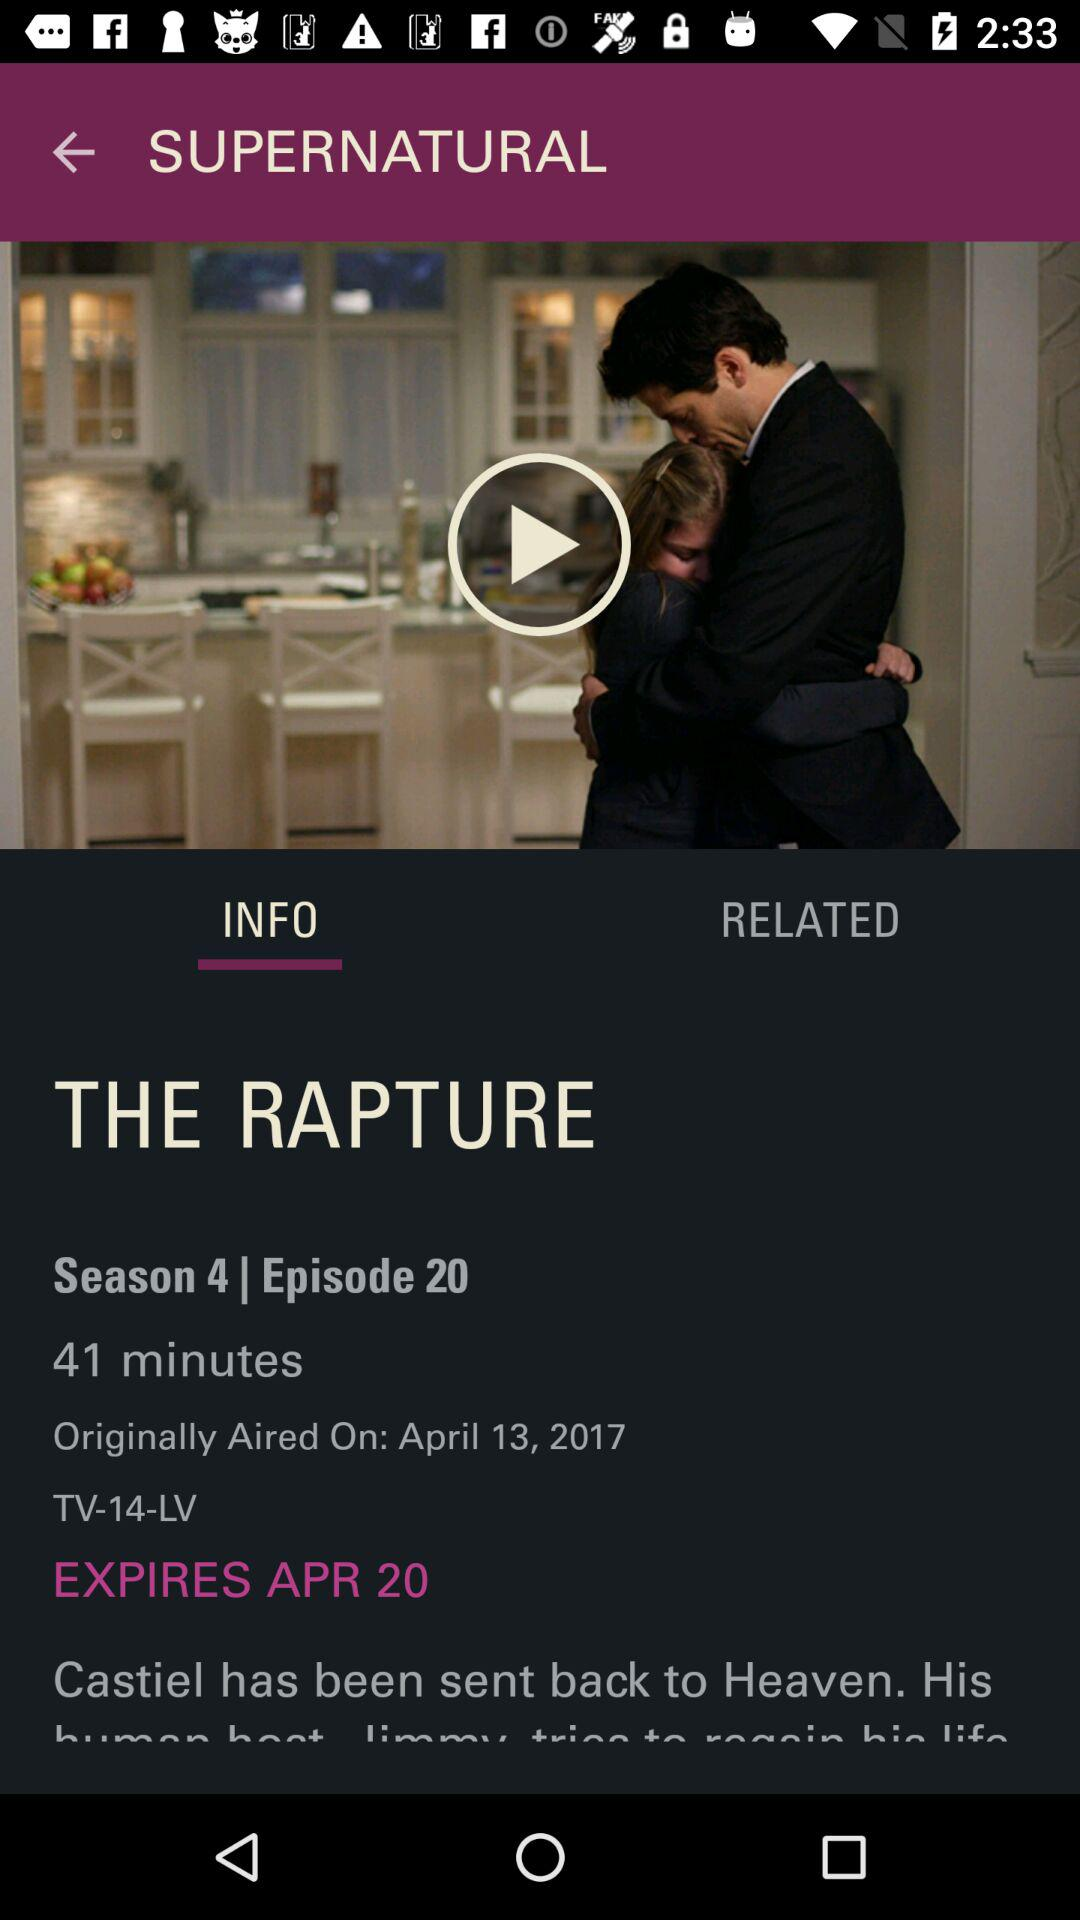How many episodes are there?
When the provided information is insufficient, respond with <no answer>. <no answer> 